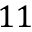Convert formula to latex. <formula><loc_0><loc_0><loc_500><loc_500>1 1</formula> 